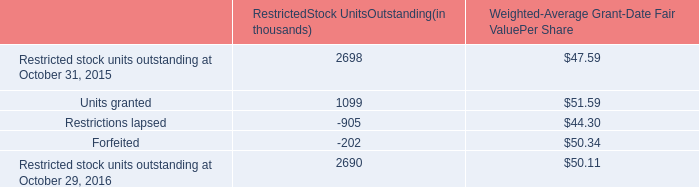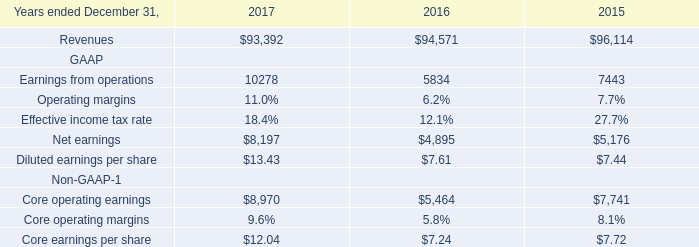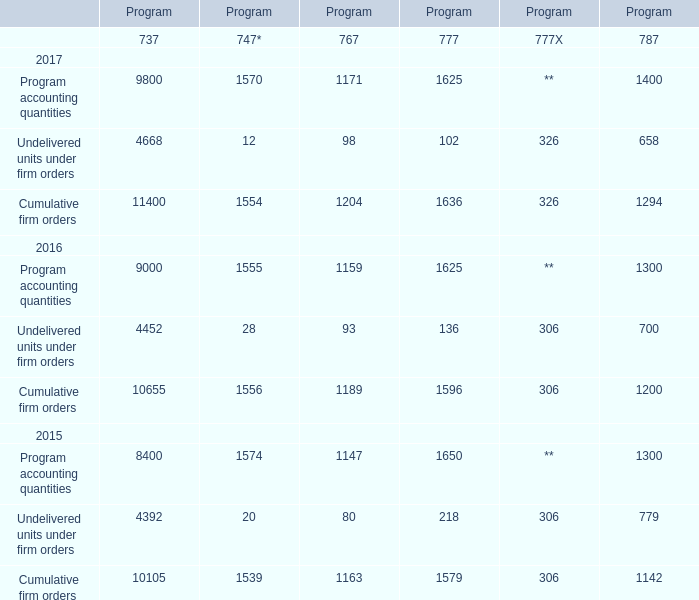What's the increasing rate of program accounting quantities of 737 in 2017? 
Computations: ((9800 - 9000) / 9000)
Answer: 0.08889. 